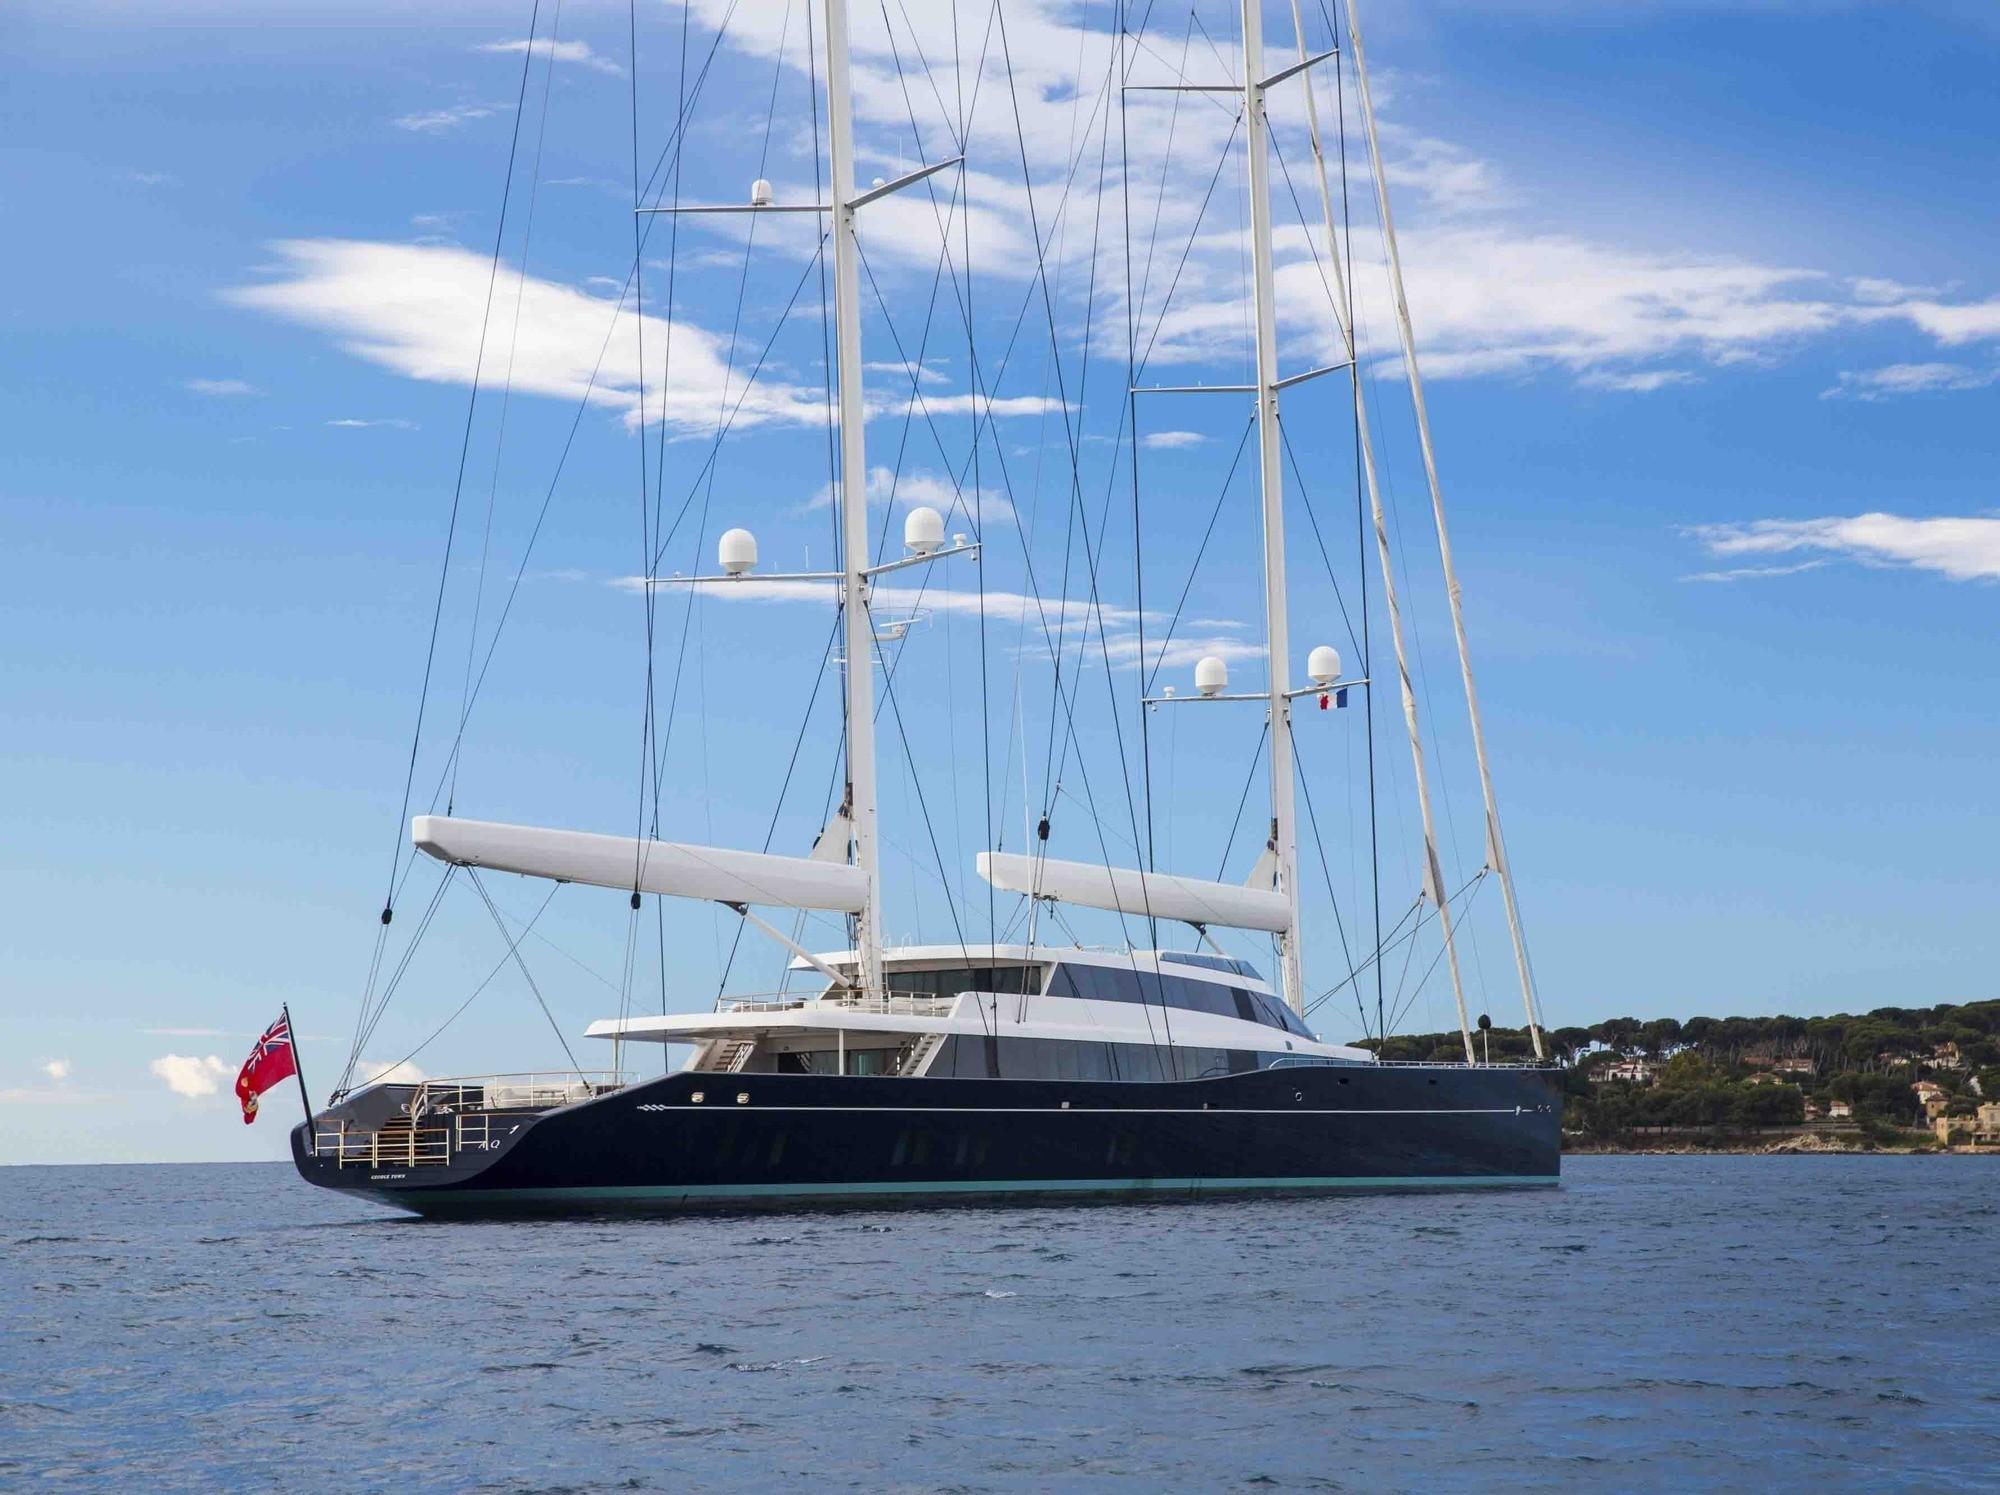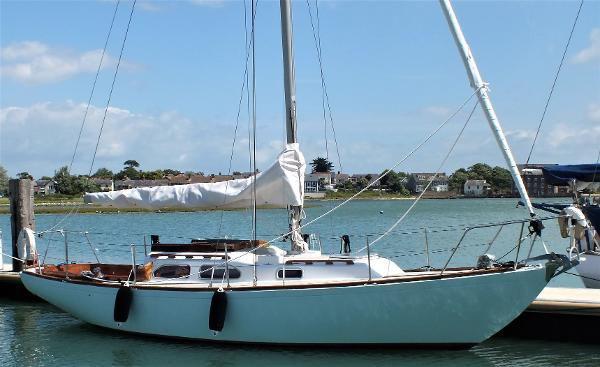The first image is the image on the left, the second image is the image on the right. Examine the images to the left and right. Is the description "The left image shows a boat with a dark exterior, furled sails and a flag at one end." accurate? Answer yes or no. Yes. 